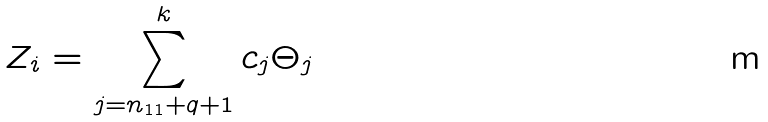<formula> <loc_0><loc_0><loc_500><loc_500>Z _ { i } = \sum _ { j = n _ { 1 1 } + q + 1 } ^ { k } c _ { j } \Theta _ { j }</formula> 